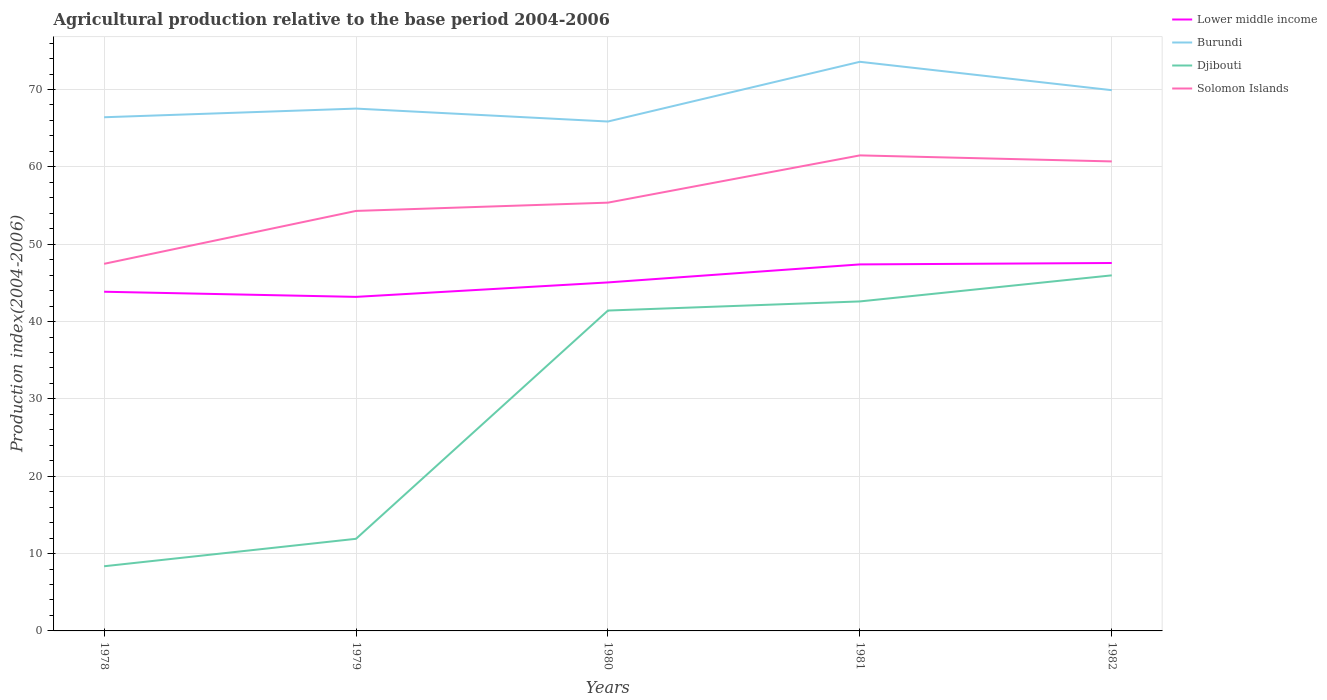Is the number of lines equal to the number of legend labels?
Give a very brief answer. Yes. Across all years, what is the maximum agricultural production index in Lower middle income?
Give a very brief answer. 43.19. In which year was the agricultural production index in Solomon Islands maximum?
Ensure brevity in your answer.  1978. What is the total agricultural production index in Djibouti in the graph?
Provide a succinct answer. -37.61. What is the difference between the highest and the second highest agricultural production index in Djibouti?
Offer a very short reply. 37.61. How many lines are there?
Offer a terse response. 4. What is the difference between two consecutive major ticks on the Y-axis?
Your answer should be compact. 10. Are the values on the major ticks of Y-axis written in scientific E-notation?
Provide a short and direct response. No. Where does the legend appear in the graph?
Provide a short and direct response. Top right. How many legend labels are there?
Your answer should be compact. 4. How are the legend labels stacked?
Provide a succinct answer. Vertical. What is the title of the graph?
Provide a short and direct response. Agricultural production relative to the base period 2004-2006. Does "High income" appear as one of the legend labels in the graph?
Keep it short and to the point. No. What is the label or title of the X-axis?
Your answer should be compact. Years. What is the label or title of the Y-axis?
Keep it short and to the point. Production index(2004-2006). What is the Production index(2004-2006) of Lower middle income in 1978?
Offer a very short reply. 43.85. What is the Production index(2004-2006) of Burundi in 1978?
Provide a succinct answer. 66.41. What is the Production index(2004-2006) of Djibouti in 1978?
Make the answer very short. 8.36. What is the Production index(2004-2006) in Solomon Islands in 1978?
Your answer should be compact. 47.46. What is the Production index(2004-2006) in Lower middle income in 1979?
Provide a short and direct response. 43.19. What is the Production index(2004-2006) in Burundi in 1979?
Offer a terse response. 67.53. What is the Production index(2004-2006) in Djibouti in 1979?
Your answer should be compact. 11.91. What is the Production index(2004-2006) in Solomon Islands in 1979?
Keep it short and to the point. 54.3. What is the Production index(2004-2006) in Lower middle income in 1980?
Provide a succinct answer. 45.06. What is the Production index(2004-2006) in Burundi in 1980?
Your answer should be compact. 65.86. What is the Production index(2004-2006) of Djibouti in 1980?
Make the answer very short. 41.42. What is the Production index(2004-2006) of Solomon Islands in 1980?
Provide a short and direct response. 55.37. What is the Production index(2004-2006) in Lower middle income in 1981?
Give a very brief answer. 47.38. What is the Production index(2004-2006) in Burundi in 1981?
Provide a short and direct response. 73.58. What is the Production index(2004-2006) in Djibouti in 1981?
Offer a terse response. 42.6. What is the Production index(2004-2006) of Solomon Islands in 1981?
Provide a short and direct response. 61.48. What is the Production index(2004-2006) in Lower middle income in 1982?
Provide a short and direct response. 47.57. What is the Production index(2004-2006) of Burundi in 1982?
Give a very brief answer. 69.91. What is the Production index(2004-2006) of Djibouti in 1982?
Offer a terse response. 45.97. What is the Production index(2004-2006) in Solomon Islands in 1982?
Your answer should be compact. 60.7. Across all years, what is the maximum Production index(2004-2006) in Lower middle income?
Your answer should be very brief. 47.57. Across all years, what is the maximum Production index(2004-2006) in Burundi?
Make the answer very short. 73.58. Across all years, what is the maximum Production index(2004-2006) of Djibouti?
Offer a very short reply. 45.97. Across all years, what is the maximum Production index(2004-2006) of Solomon Islands?
Give a very brief answer. 61.48. Across all years, what is the minimum Production index(2004-2006) in Lower middle income?
Provide a short and direct response. 43.19. Across all years, what is the minimum Production index(2004-2006) of Burundi?
Your response must be concise. 65.86. Across all years, what is the minimum Production index(2004-2006) in Djibouti?
Your answer should be compact. 8.36. Across all years, what is the minimum Production index(2004-2006) of Solomon Islands?
Provide a short and direct response. 47.46. What is the total Production index(2004-2006) of Lower middle income in the graph?
Your answer should be very brief. 227.05. What is the total Production index(2004-2006) in Burundi in the graph?
Provide a succinct answer. 343.29. What is the total Production index(2004-2006) in Djibouti in the graph?
Your answer should be very brief. 150.26. What is the total Production index(2004-2006) of Solomon Islands in the graph?
Your answer should be very brief. 279.31. What is the difference between the Production index(2004-2006) of Lower middle income in 1978 and that in 1979?
Your answer should be compact. 0.67. What is the difference between the Production index(2004-2006) in Burundi in 1978 and that in 1979?
Keep it short and to the point. -1.12. What is the difference between the Production index(2004-2006) in Djibouti in 1978 and that in 1979?
Ensure brevity in your answer.  -3.55. What is the difference between the Production index(2004-2006) in Solomon Islands in 1978 and that in 1979?
Ensure brevity in your answer.  -6.84. What is the difference between the Production index(2004-2006) of Lower middle income in 1978 and that in 1980?
Ensure brevity in your answer.  -1.2. What is the difference between the Production index(2004-2006) in Burundi in 1978 and that in 1980?
Your answer should be very brief. 0.55. What is the difference between the Production index(2004-2006) of Djibouti in 1978 and that in 1980?
Your answer should be compact. -33.06. What is the difference between the Production index(2004-2006) of Solomon Islands in 1978 and that in 1980?
Your answer should be very brief. -7.91. What is the difference between the Production index(2004-2006) of Lower middle income in 1978 and that in 1981?
Provide a succinct answer. -3.53. What is the difference between the Production index(2004-2006) in Burundi in 1978 and that in 1981?
Offer a terse response. -7.17. What is the difference between the Production index(2004-2006) of Djibouti in 1978 and that in 1981?
Your answer should be compact. -34.24. What is the difference between the Production index(2004-2006) of Solomon Islands in 1978 and that in 1981?
Give a very brief answer. -14.02. What is the difference between the Production index(2004-2006) of Lower middle income in 1978 and that in 1982?
Give a very brief answer. -3.71. What is the difference between the Production index(2004-2006) in Djibouti in 1978 and that in 1982?
Give a very brief answer. -37.61. What is the difference between the Production index(2004-2006) in Solomon Islands in 1978 and that in 1982?
Provide a short and direct response. -13.24. What is the difference between the Production index(2004-2006) in Lower middle income in 1979 and that in 1980?
Provide a short and direct response. -1.87. What is the difference between the Production index(2004-2006) in Burundi in 1979 and that in 1980?
Provide a short and direct response. 1.67. What is the difference between the Production index(2004-2006) in Djibouti in 1979 and that in 1980?
Provide a short and direct response. -29.51. What is the difference between the Production index(2004-2006) in Solomon Islands in 1979 and that in 1980?
Your answer should be compact. -1.07. What is the difference between the Production index(2004-2006) of Lower middle income in 1979 and that in 1981?
Offer a terse response. -4.2. What is the difference between the Production index(2004-2006) in Burundi in 1979 and that in 1981?
Offer a very short reply. -6.05. What is the difference between the Production index(2004-2006) in Djibouti in 1979 and that in 1981?
Ensure brevity in your answer.  -30.69. What is the difference between the Production index(2004-2006) of Solomon Islands in 1979 and that in 1981?
Provide a short and direct response. -7.18. What is the difference between the Production index(2004-2006) of Lower middle income in 1979 and that in 1982?
Ensure brevity in your answer.  -4.38. What is the difference between the Production index(2004-2006) of Burundi in 1979 and that in 1982?
Provide a short and direct response. -2.38. What is the difference between the Production index(2004-2006) of Djibouti in 1979 and that in 1982?
Ensure brevity in your answer.  -34.06. What is the difference between the Production index(2004-2006) in Lower middle income in 1980 and that in 1981?
Your response must be concise. -2.33. What is the difference between the Production index(2004-2006) in Burundi in 1980 and that in 1981?
Your answer should be compact. -7.72. What is the difference between the Production index(2004-2006) in Djibouti in 1980 and that in 1981?
Your answer should be very brief. -1.18. What is the difference between the Production index(2004-2006) in Solomon Islands in 1980 and that in 1981?
Keep it short and to the point. -6.11. What is the difference between the Production index(2004-2006) of Lower middle income in 1980 and that in 1982?
Ensure brevity in your answer.  -2.51. What is the difference between the Production index(2004-2006) of Burundi in 1980 and that in 1982?
Give a very brief answer. -4.05. What is the difference between the Production index(2004-2006) in Djibouti in 1980 and that in 1982?
Your answer should be compact. -4.55. What is the difference between the Production index(2004-2006) in Solomon Islands in 1980 and that in 1982?
Your answer should be very brief. -5.33. What is the difference between the Production index(2004-2006) in Lower middle income in 1981 and that in 1982?
Your answer should be compact. -0.18. What is the difference between the Production index(2004-2006) in Burundi in 1981 and that in 1982?
Give a very brief answer. 3.67. What is the difference between the Production index(2004-2006) in Djibouti in 1981 and that in 1982?
Keep it short and to the point. -3.37. What is the difference between the Production index(2004-2006) of Solomon Islands in 1981 and that in 1982?
Provide a succinct answer. 0.78. What is the difference between the Production index(2004-2006) in Lower middle income in 1978 and the Production index(2004-2006) in Burundi in 1979?
Offer a very short reply. -23.68. What is the difference between the Production index(2004-2006) in Lower middle income in 1978 and the Production index(2004-2006) in Djibouti in 1979?
Give a very brief answer. 31.94. What is the difference between the Production index(2004-2006) of Lower middle income in 1978 and the Production index(2004-2006) of Solomon Islands in 1979?
Your response must be concise. -10.45. What is the difference between the Production index(2004-2006) in Burundi in 1978 and the Production index(2004-2006) in Djibouti in 1979?
Your answer should be compact. 54.5. What is the difference between the Production index(2004-2006) in Burundi in 1978 and the Production index(2004-2006) in Solomon Islands in 1979?
Offer a very short reply. 12.11. What is the difference between the Production index(2004-2006) in Djibouti in 1978 and the Production index(2004-2006) in Solomon Islands in 1979?
Offer a terse response. -45.94. What is the difference between the Production index(2004-2006) in Lower middle income in 1978 and the Production index(2004-2006) in Burundi in 1980?
Your response must be concise. -22.01. What is the difference between the Production index(2004-2006) of Lower middle income in 1978 and the Production index(2004-2006) of Djibouti in 1980?
Your response must be concise. 2.43. What is the difference between the Production index(2004-2006) in Lower middle income in 1978 and the Production index(2004-2006) in Solomon Islands in 1980?
Provide a short and direct response. -11.52. What is the difference between the Production index(2004-2006) of Burundi in 1978 and the Production index(2004-2006) of Djibouti in 1980?
Provide a short and direct response. 24.99. What is the difference between the Production index(2004-2006) of Burundi in 1978 and the Production index(2004-2006) of Solomon Islands in 1980?
Your answer should be very brief. 11.04. What is the difference between the Production index(2004-2006) of Djibouti in 1978 and the Production index(2004-2006) of Solomon Islands in 1980?
Offer a terse response. -47.01. What is the difference between the Production index(2004-2006) of Lower middle income in 1978 and the Production index(2004-2006) of Burundi in 1981?
Offer a terse response. -29.73. What is the difference between the Production index(2004-2006) in Lower middle income in 1978 and the Production index(2004-2006) in Djibouti in 1981?
Your response must be concise. 1.25. What is the difference between the Production index(2004-2006) of Lower middle income in 1978 and the Production index(2004-2006) of Solomon Islands in 1981?
Your answer should be very brief. -17.63. What is the difference between the Production index(2004-2006) of Burundi in 1978 and the Production index(2004-2006) of Djibouti in 1981?
Offer a very short reply. 23.81. What is the difference between the Production index(2004-2006) in Burundi in 1978 and the Production index(2004-2006) in Solomon Islands in 1981?
Ensure brevity in your answer.  4.93. What is the difference between the Production index(2004-2006) of Djibouti in 1978 and the Production index(2004-2006) of Solomon Islands in 1981?
Provide a short and direct response. -53.12. What is the difference between the Production index(2004-2006) in Lower middle income in 1978 and the Production index(2004-2006) in Burundi in 1982?
Provide a short and direct response. -26.06. What is the difference between the Production index(2004-2006) in Lower middle income in 1978 and the Production index(2004-2006) in Djibouti in 1982?
Your answer should be very brief. -2.12. What is the difference between the Production index(2004-2006) of Lower middle income in 1978 and the Production index(2004-2006) of Solomon Islands in 1982?
Ensure brevity in your answer.  -16.85. What is the difference between the Production index(2004-2006) in Burundi in 1978 and the Production index(2004-2006) in Djibouti in 1982?
Make the answer very short. 20.44. What is the difference between the Production index(2004-2006) of Burundi in 1978 and the Production index(2004-2006) of Solomon Islands in 1982?
Ensure brevity in your answer.  5.71. What is the difference between the Production index(2004-2006) of Djibouti in 1978 and the Production index(2004-2006) of Solomon Islands in 1982?
Ensure brevity in your answer.  -52.34. What is the difference between the Production index(2004-2006) in Lower middle income in 1979 and the Production index(2004-2006) in Burundi in 1980?
Provide a succinct answer. -22.67. What is the difference between the Production index(2004-2006) in Lower middle income in 1979 and the Production index(2004-2006) in Djibouti in 1980?
Your answer should be compact. 1.77. What is the difference between the Production index(2004-2006) of Lower middle income in 1979 and the Production index(2004-2006) of Solomon Islands in 1980?
Offer a terse response. -12.18. What is the difference between the Production index(2004-2006) of Burundi in 1979 and the Production index(2004-2006) of Djibouti in 1980?
Keep it short and to the point. 26.11. What is the difference between the Production index(2004-2006) of Burundi in 1979 and the Production index(2004-2006) of Solomon Islands in 1980?
Your answer should be compact. 12.16. What is the difference between the Production index(2004-2006) of Djibouti in 1979 and the Production index(2004-2006) of Solomon Islands in 1980?
Provide a succinct answer. -43.46. What is the difference between the Production index(2004-2006) in Lower middle income in 1979 and the Production index(2004-2006) in Burundi in 1981?
Ensure brevity in your answer.  -30.39. What is the difference between the Production index(2004-2006) of Lower middle income in 1979 and the Production index(2004-2006) of Djibouti in 1981?
Your response must be concise. 0.59. What is the difference between the Production index(2004-2006) in Lower middle income in 1979 and the Production index(2004-2006) in Solomon Islands in 1981?
Offer a very short reply. -18.29. What is the difference between the Production index(2004-2006) of Burundi in 1979 and the Production index(2004-2006) of Djibouti in 1981?
Your answer should be very brief. 24.93. What is the difference between the Production index(2004-2006) in Burundi in 1979 and the Production index(2004-2006) in Solomon Islands in 1981?
Provide a succinct answer. 6.05. What is the difference between the Production index(2004-2006) in Djibouti in 1979 and the Production index(2004-2006) in Solomon Islands in 1981?
Your answer should be very brief. -49.57. What is the difference between the Production index(2004-2006) of Lower middle income in 1979 and the Production index(2004-2006) of Burundi in 1982?
Provide a short and direct response. -26.72. What is the difference between the Production index(2004-2006) of Lower middle income in 1979 and the Production index(2004-2006) of Djibouti in 1982?
Your answer should be very brief. -2.78. What is the difference between the Production index(2004-2006) of Lower middle income in 1979 and the Production index(2004-2006) of Solomon Islands in 1982?
Offer a terse response. -17.51. What is the difference between the Production index(2004-2006) of Burundi in 1979 and the Production index(2004-2006) of Djibouti in 1982?
Offer a very short reply. 21.56. What is the difference between the Production index(2004-2006) in Burundi in 1979 and the Production index(2004-2006) in Solomon Islands in 1982?
Your response must be concise. 6.83. What is the difference between the Production index(2004-2006) of Djibouti in 1979 and the Production index(2004-2006) of Solomon Islands in 1982?
Offer a terse response. -48.79. What is the difference between the Production index(2004-2006) in Lower middle income in 1980 and the Production index(2004-2006) in Burundi in 1981?
Give a very brief answer. -28.52. What is the difference between the Production index(2004-2006) of Lower middle income in 1980 and the Production index(2004-2006) of Djibouti in 1981?
Provide a short and direct response. 2.46. What is the difference between the Production index(2004-2006) in Lower middle income in 1980 and the Production index(2004-2006) in Solomon Islands in 1981?
Your answer should be compact. -16.42. What is the difference between the Production index(2004-2006) in Burundi in 1980 and the Production index(2004-2006) in Djibouti in 1981?
Give a very brief answer. 23.26. What is the difference between the Production index(2004-2006) of Burundi in 1980 and the Production index(2004-2006) of Solomon Islands in 1981?
Offer a terse response. 4.38. What is the difference between the Production index(2004-2006) of Djibouti in 1980 and the Production index(2004-2006) of Solomon Islands in 1981?
Offer a terse response. -20.06. What is the difference between the Production index(2004-2006) in Lower middle income in 1980 and the Production index(2004-2006) in Burundi in 1982?
Give a very brief answer. -24.85. What is the difference between the Production index(2004-2006) in Lower middle income in 1980 and the Production index(2004-2006) in Djibouti in 1982?
Your response must be concise. -0.91. What is the difference between the Production index(2004-2006) of Lower middle income in 1980 and the Production index(2004-2006) of Solomon Islands in 1982?
Provide a succinct answer. -15.64. What is the difference between the Production index(2004-2006) of Burundi in 1980 and the Production index(2004-2006) of Djibouti in 1982?
Keep it short and to the point. 19.89. What is the difference between the Production index(2004-2006) in Burundi in 1980 and the Production index(2004-2006) in Solomon Islands in 1982?
Keep it short and to the point. 5.16. What is the difference between the Production index(2004-2006) in Djibouti in 1980 and the Production index(2004-2006) in Solomon Islands in 1982?
Make the answer very short. -19.28. What is the difference between the Production index(2004-2006) in Lower middle income in 1981 and the Production index(2004-2006) in Burundi in 1982?
Provide a succinct answer. -22.53. What is the difference between the Production index(2004-2006) of Lower middle income in 1981 and the Production index(2004-2006) of Djibouti in 1982?
Your response must be concise. 1.41. What is the difference between the Production index(2004-2006) in Lower middle income in 1981 and the Production index(2004-2006) in Solomon Islands in 1982?
Provide a short and direct response. -13.32. What is the difference between the Production index(2004-2006) of Burundi in 1981 and the Production index(2004-2006) of Djibouti in 1982?
Ensure brevity in your answer.  27.61. What is the difference between the Production index(2004-2006) in Burundi in 1981 and the Production index(2004-2006) in Solomon Islands in 1982?
Keep it short and to the point. 12.88. What is the difference between the Production index(2004-2006) of Djibouti in 1981 and the Production index(2004-2006) of Solomon Islands in 1982?
Offer a terse response. -18.1. What is the average Production index(2004-2006) of Lower middle income per year?
Ensure brevity in your answer.  45.41. What is the average Production index(2004-2006) of Burundi per year?
Your answer should be very brief. 68.66. What is the average Production index(2004-2006) in Djibouti per year?
Offer a very short reply. 30.05. What is the average Production index(2004-2006) of Solomon Islands per year?
Give a very brief answer. 55.86. In the year 1978, what is the difference between the Production index(2004-2006) in Lower middle income and Production index(2004-2006) in Burundi?
Offer a very short reply. -22.56. In the year 1978, what is the difference between the Production index(2004-2006) in Lower middle income and Production index(2004-2006) in Djibouti?
Keep it short and to the point. 35.49. In the year 1978, what is the difference between the Production index(2004-2006) of Lower middle income and Production index(2004-2006) of Solomon Islands?
Your answer should be very brief. -3.61. In the year 1978, what is the difference between the Production index(2004-2006) in Burundi and Production index(2004-2006) in Djibouti?
Your answer should be very brief. 58.05. In the year 1978, what is the difference between the Production index(2004-2006) in Burundi and Production index(2004-2006) in Solomon Islands?
Ensure brevity in your answer.  18.95. In the year 1978, what is the difference between the Production index(2004-2006) in Djibouti and Production index(2004-2006) in Solomon Islands?
Offer a terse response. -39.1. In the year 1979, what is the difference between the Production index(2004-2006) of Lower middle income and Production index(2004-2006) of Burundi?
Provide a short and direct response. -24.34. In the year 1979, what is the difference between the Production index(2004-2006) of Lower middle income and Production index(2004-2006) of Djibouti?
Give a very brief answer. 31.28. In the year 1979, what is the difference between the Production index(2004-2006) in Lower middle income and Production index(2004-2006) in Solomon Islands?
Provide a short and direct response. -11.11. In the year 1979, what is the difference between the Production index(2004-2006) of Burundi and Production index(2004-2006) of Djibouti?
Ensure brevity in your answer.  55.62. In the year 1979, what is the difference between the Production index(2004-2006) of Burundi and Production index(2004-2006) of Solomon Islands?
Keep it short and to the point. 13.23. In the year 1979, what is the difference between the Production index(2004-2006) of Djibouti and Production index(2004-2006) of Solomon Islands?
Your answer should be very brief. -42.39. In the year 1980, what is the difference between the Production index(2004-2006) of Lower middle income and Production index(2004-2006) of Burundi?
Keep it short and to the point. -20.8. In the year 1980, what is the difference between the Production index(2004-2006) of Lower middle income and Production index(2004-2006) of Djibouti?
Keep it short and to the point. 3.64. In the year 1980, what is the difference between the Production index(2004-2006) in Lower middle income and Production index(2004-2006) in Solomon Islands?
Offer a terse response. -10.31. In the year 1980, what is the difference between the Production index(2004-2006) of Burundi and Production index(2004-2006) of Djibouti?
Offer a very short reply. 24.44. In the year 1980, what is the difference between the Production index(2004-2006) in Burundi and Production index(2004-2006) in Solomon Islands?
Your answer should be compact. 10.49. In the year 1980, what is the difference between the Production index(2004-2006) in Djibouti and Production index(2004-2006) in Solomon Islands?
Ensure brevity in your answer.  -13.95. In the year 1981, what is the difference between the Production index(2004-2006) in Lower middle income and Production index(2004-2006) in Burundi?
Provide a short and direct response. -26.2. In the year 1981, what is the difference between the Production index(2004-2006) of Lower middle income and Production index(2004-2006) of Djibouti?
Offer a very short reply. 4.78. In the year 1981, what is the difference between the Production index(2004-2006) of Lower middle income and Production index(2004-2006) of Solomon Islands?
Provide a short and direct response. -14.1. In the year 1981, what is the difference between the Production index(2004-2006) of Burundi and Production index(2004-2006) of Djibouti?
Keep it short and to the point. 30.98. In the year 1981, what is the difference between the Production index(2004-2006) in Djibouti and Production index(2004-2006) in Solomon Islands?
Ensure brevity in your answer.  -18.88. In the year 1982, what is the difference between the Production index(2004-2006) of Lower middle income and Production index(2004-2006) of Burundi?
Keep it short and to the point. -22.34. In the year 1982, what is the difference between the Production index(2004-2006) in Lower middle income and Production index(2004-2006) in Djibouti?
Your response must be concise. 1.6. In the year 1982, what is the difference between the Production index(2004-2006) of Lower middle income and Production index(2004-2006) of Solomon Islands?
Keep it short and to the point. -13.13. In the year 1982, what is the difference between the Production index(2004-2006) in Burundi and Production index(2004-2006) in Djibouti?
Provide a short and direct response. 23.94. In the year 1982, what is the difference between the Production index(2004-2006) of Burundi and Production index(2004-2006) of Solomon Islands?
Give a very brief answer. 9.21. In the year 1982, what is the difference between the Production index(2004-2006) of Djibouti and Production index(2004-2006) of Solomon Islands?
Make the answer very short. -14.73. What is the ratio of the Production index(2004-2006) of Lower middle income in 1978 to that in 1979?
Provide a succinct answer. 1.02. What is the ratio of the Production index(2004-2006) of Burundi in 1978 to that in 1979?
Give a very brief answer. 0.98. What is the ratio of the Production index(2004-2006) of Djibouti in 1978 to that in 1979?
Keep it short and to the point. 0.7. What is the ratio of the Production index(2004-2006) of Solomon Islands in 1978 to that in 1979?
Provide a succinct answer. 0.87. What is the ratio of the Production index(2004-2006) of Lower middle income in 1978 to that in 1980?
Offer a very short reply. 0.97. What is the ratio of the Production index(2004-2006) of Burundi in 1978 to that in 1980?
Offer a terse response. 1.01. What is the ratio of the Production index(2004-2006) in Djibouti in 1978 to that in 1980?
Your answer should be compact. 0.2. What is the ratio of the Production index(2004-2006) in Solomon Islands in 1978 to that in 1980?
Your answer should be very brief. 0.86. What is the ratio of the Production index(2004-2006) of Lower middle income in 1978 to that in 1981?
Your response must be concise. 0.93. What is the ratio of the Production index(2004-2006) of Burundi in 1978 to that in 1981?
Provide a succinct answer. 0.9. What is the ratio of the Production index(2004-2006) in Djibouti in 1978 to that in 1981?
Your answer should be very brief. 0.2. What is the ratio of the Production index(2004-2006) of Solomon Islands in 1978 to that in 1981?
Offer a very short reply. 0.77. What is the ratio of the Production index(2004-2006) in Lower middle income in 1978 to that in 1982?
Offer a very short reply. 0.92. What is the ratio of the Production index(2004-2006) of Burundi in 1978 to that in 1982?
Keep it short and to the point. 0.95. What is the ratio of the Production index(2004-2006) of Djibouti in 1978 to that in 1982?
Your answer should be compact. 0.18. What is the ratio of the Production index(2004-2006) of Solomon Islands in 1978 to that in 1982?
Provide a succinct answer. 0.78. What is the ratio of the Production index(2004-2006) in Lower middle income in 1979 to that in 1980?
Ensure brevity in your answer.  0.96. What is the ratio of the Production index(2004-2006) in Burundi in 1979 to that in 1980?
Ensure brevity in your answer.  1.03. What is the ratio of the Production index(2004-2006) of Djibouti in 1979 to that in 1980?
Offer a very short reply. 0.29. What is the ratio of the Production index(2004-2006) of Solomon Islands in 1979 to that in 1980?
Make the answer very short. 0.98. What is the ratio of the Production index(2004-2006) in Lower middle income in 1979 to that in 1981?
Provide a succinct answer. 0.91. What is the ratio of the Production index(2004-2006) of Burundi in 1979 to that in 1981?
Offer a very short reply. 0.92. What is the ratio of the Production index(2004-2006) of Djibouti in 1979 to that in 1981?
Your response must be concise. 0.28. What is the ratio of the Production index(2004-2006) of Solomon Islands in 1979 to that in 1981?
Offer a very short reply. 0.88. What is the ratio of the Production index(2004-2006) in Lower middle income in 1979 to that in 1982?
Your response must be concise. 0.91. What is the ratio of the Production index(2004-2006) of Djibouti in 1979 to that in 1982?
Offer a very short reply. 0.26. What is the ratio of the Production index(2004-2006) of Solomon Islands in 1979 to that in 1982?
Your answer should be very brief. 0.89. What is the ratio of the Production index(2004-2006) of Lower middle income in 1980 to that in 1981?
Provide a succinct answer. 0.95. What is the ratio of the Production index(2004-2006) of Burundi in 1980 to that in 1981?
Keep it short and to the point. 0.9. What is the ratio of the Production index(2004-2006) in Djibouti in 1980 to that in 1981?
Offer a very short reply. 0.97. What is the ratio of the Production index(2004-2006) in Solomon Islands in 1980 to that in 1981?
Your answer should be very brief. 0.9. What is the ratio of the Production index(2004-2006) in Lower middle income in 1980 to that in 1982?
Give a very brief answer. 0.95. What is the ratio of the Production index(2004-2006) in Burundi in 1980 to that in 1982?
Make the answer very short. 0.94. What is the ratio of the Production index(2004-2006) in Djibouti in 1980 to that in 1982?
Provide a short and direct response. 0.9. What is the ratio of the Production index(2004-2006) of Solomon Islands in 1980 to that in 1982?
Give a very brief answer. 0.91. What is the ratio of the Production index(2004-2006) of Lower middle income in 1981 to that in 1982?
Provide a succinct answer. 1. What is the ratio of the Production index(2004-2006) of Burundi in 1981 to that in 1982?
Make the answer very short. 1.05. What is the ratio of the Production index(2004-2006) of Djibouti in 1981 to that in 1982?
Your answer should be very brief. 0.93. What is the ratio of the Production index(2004-2006) in Solomon Islands in 1981 to that in 1982?
Keep it short and to the point. 1.01. What is the difference between the highest and the second highest Production index(2004-2006) in Lower middle income?
Offer a terse response. 0.18. What is the difference between the highest and the second highest Production index(2004-2006) in Burundi?
Make the answer very short. 3.67. What is the difference between the highest and the second highest Production index(2004-2006) in Djibouti?
Ensure brevity in your answer.  3.37. What is the difference between the highest and the second highest Production index(2004-2006) in Solomon Islands?
Your answer should be very brief. 0.78. What is the difference between the highest and the lowest Production index(2004-2006) of Lower middle income?
Offer a terse response. 4.38. What is the difference between the highest and the lowest Production index(2004-2006) in Burundi?
Your response must be concise. 7.72. What is the difference between the highest and the lowest Production index(2004-2006) of Djibouti?
Provide a short and direct response. 37.61. What is the difference between the highest and the lowest Production index(2004-2006) in Solomon Islands?
Your answer should be very brief. 14.02. 